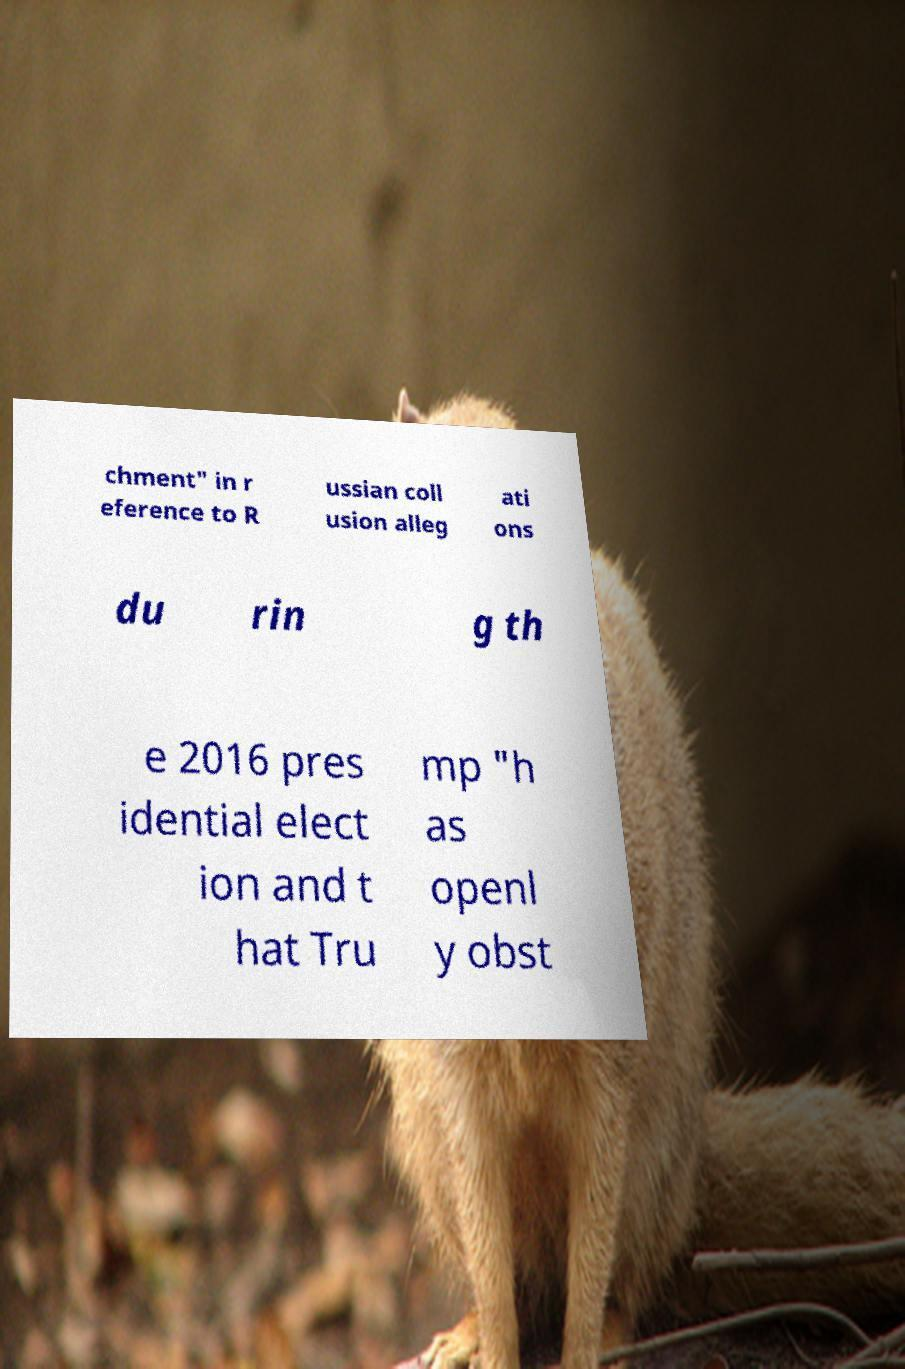For documentation purposes, I need the text within this image transcribed. Could you provide that? chment" in r eference to R ussian coll usion alleg ati ons du rin g th e 2016 pres idential elect ion and t hat Tru mp "h as openl y obst 